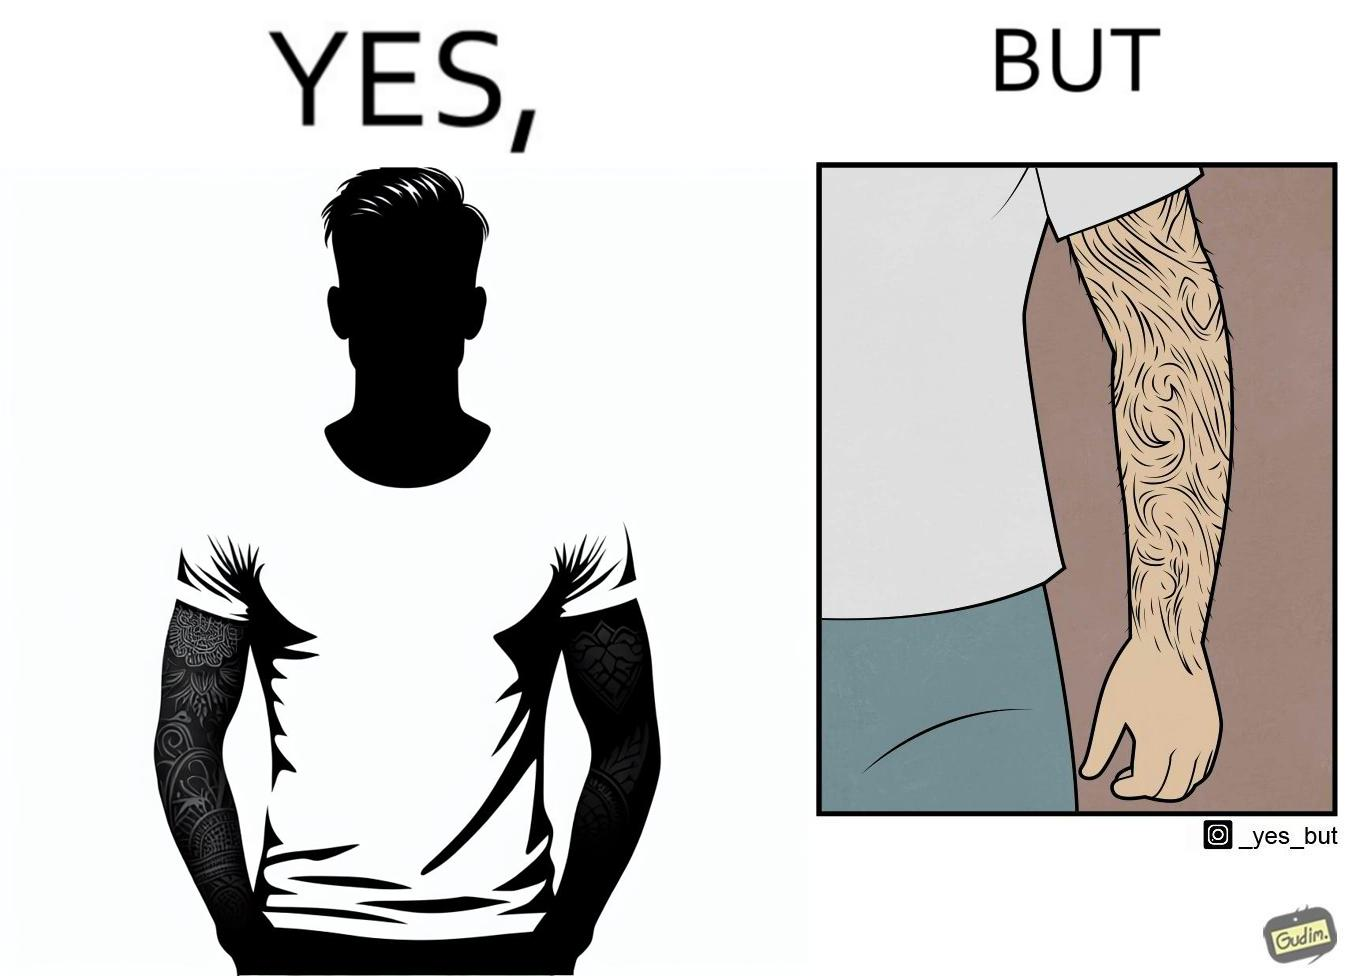What makes this image funny or satirical? The image is funny because while from the distance it seems that the man has big tattoos on both of his arms upon a closer look at the arms it turns out there is no tattoo and what seemed to be tattoos are just hairs on his arm. 